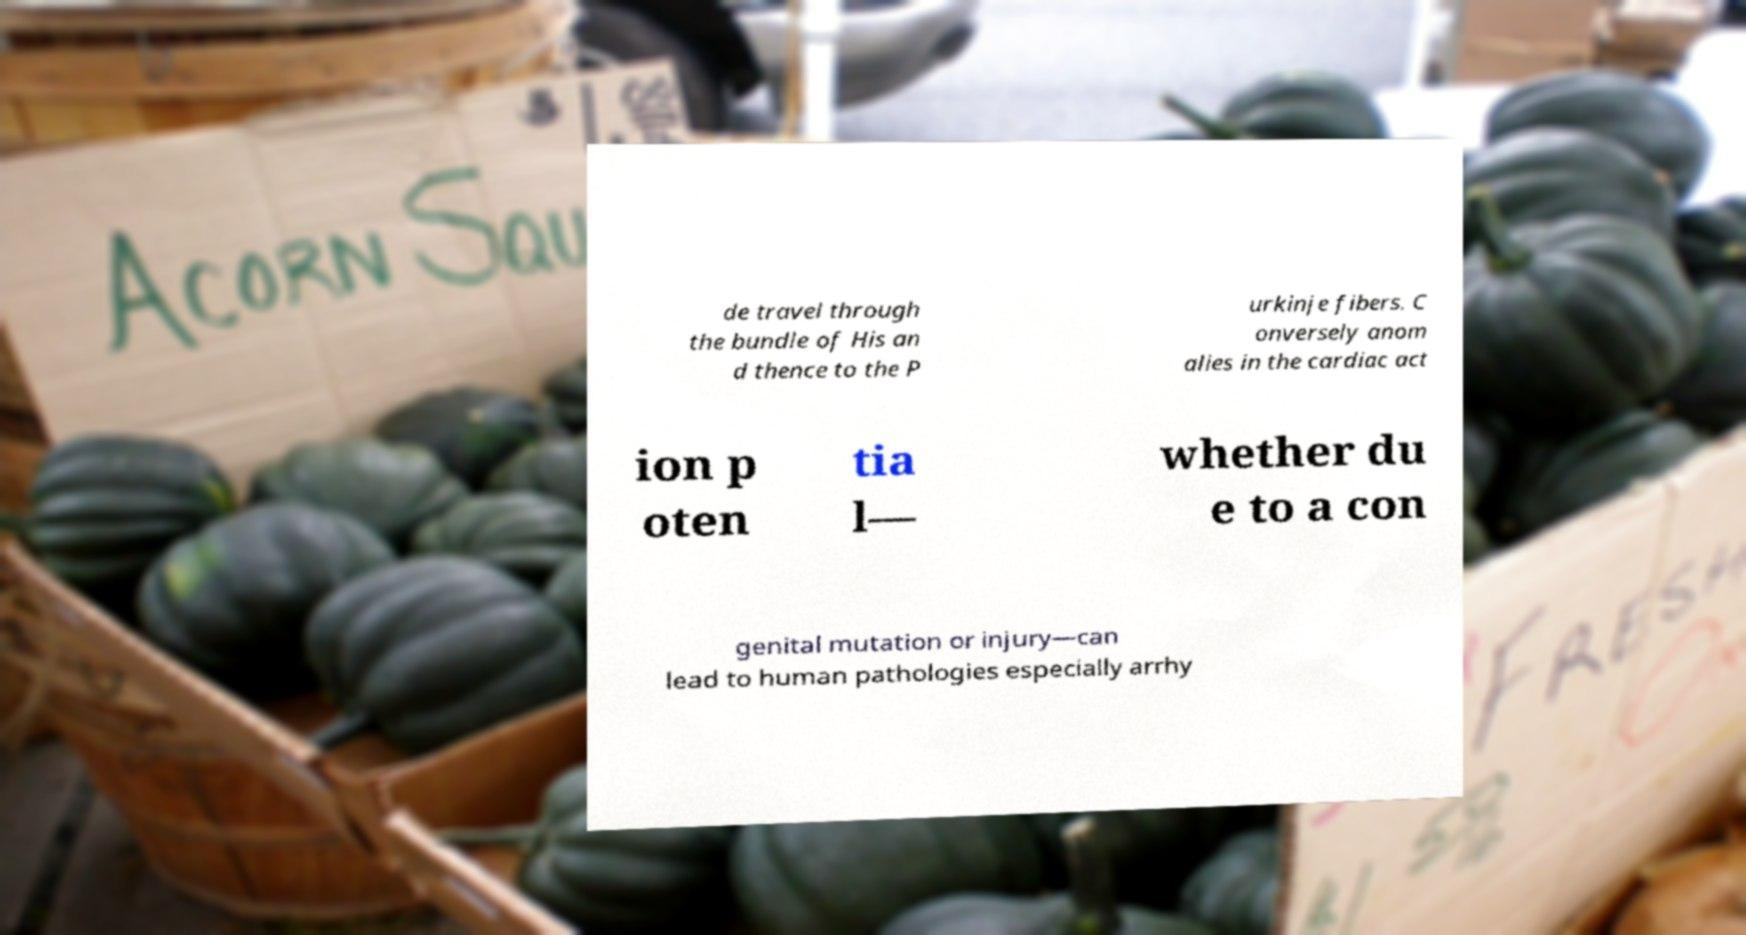Could you extract and type out the text from this image? de travel through the bundle of His an d thence to the P urkinje fibers. C onversely anom alies in the cardiac act ion p oten tia l— whether du e to a con genital mutation or injury—can lead to human pathologies especially arrhy 